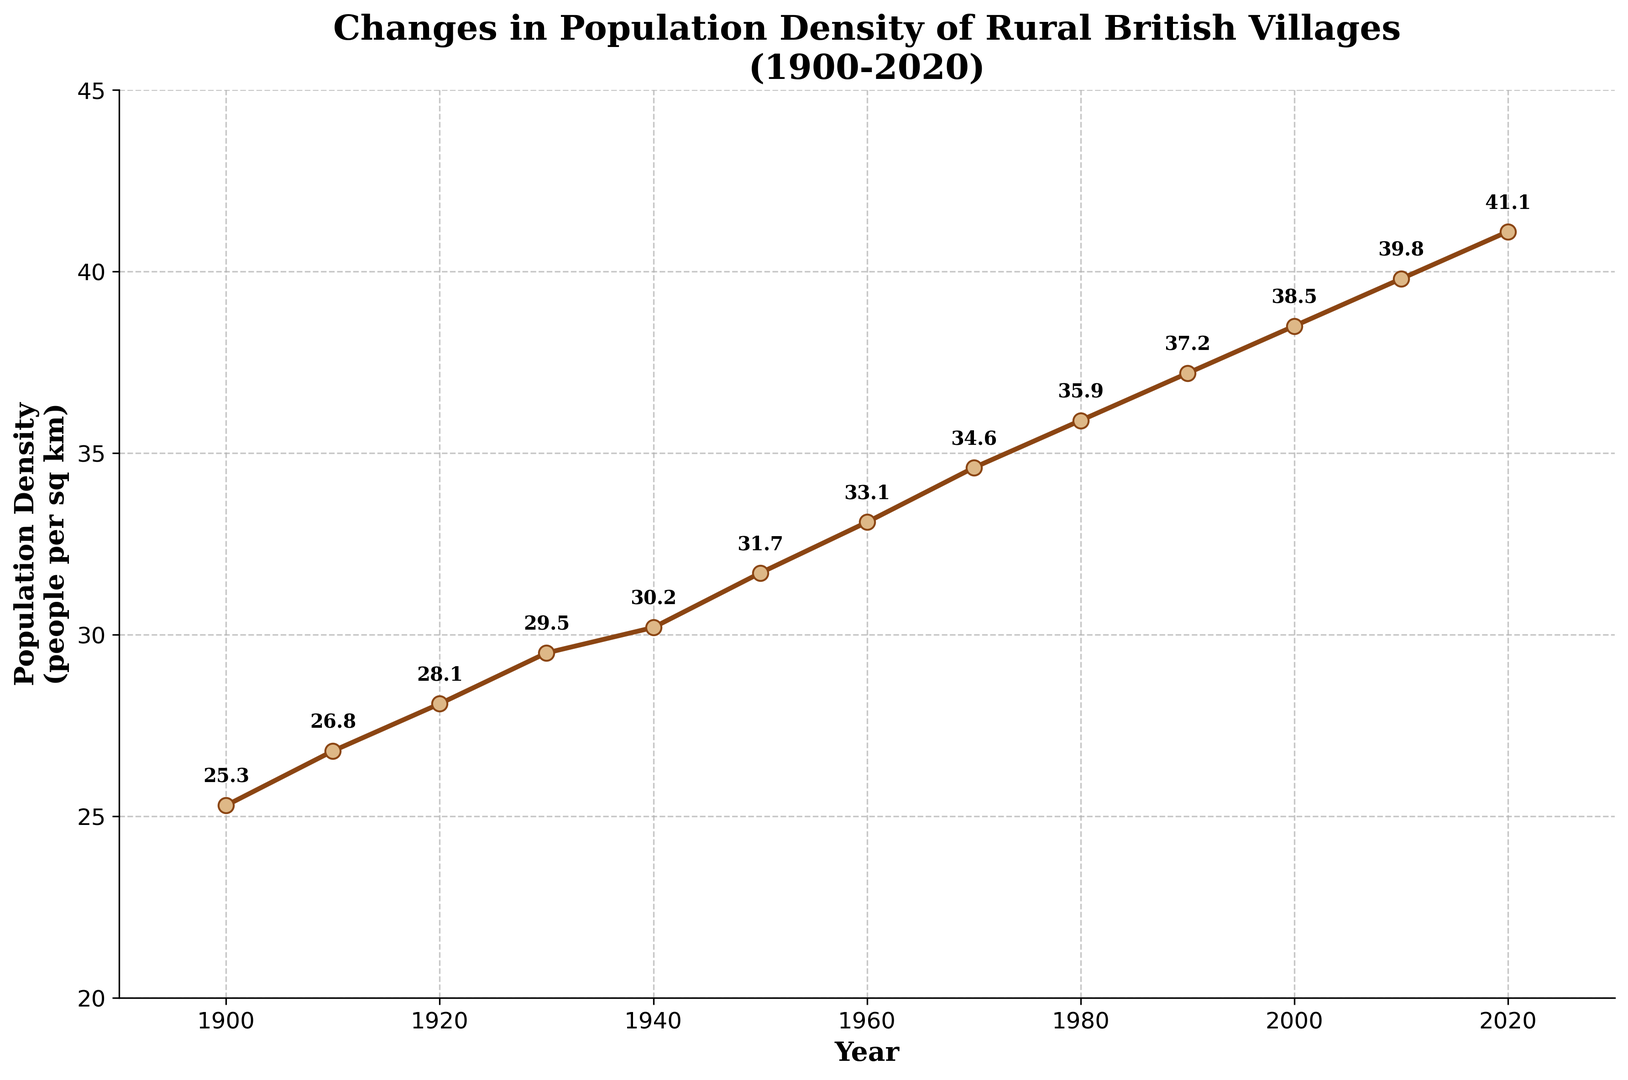How does the population density in 1920 compare to that in 2020? To find the population density difference between 1920 and 2020, look at the chart and identify the values for these years. In 1920, the population density is 28.1 people per sq km. In 2020, it is 41.1 people per sq km. The difference is calculated as 41.1 - 28.1 = 13.0.
Answer: 13.0 In which decade did the population density see the largest increase? To determine the decade with the largest increase, calculate the increase for each decade by subtracting the population density at the beginning of the decade from that at the end. Compare these increases to find the highest. The 2010s show the largest increase from 39.8 in 2010 to 41.1 in 2020, an increase of 1.3. All other decades have smaller increases.
Answer: 2010s What is the average population density from 1900 to 2020? The average population density is found by summing the population densities for all given years and dividing by the number of years. The sum of population densities is (25.3 + 26.8 + 28.1 + 29.5 + 30.2 + 31.7 + 33.1 + 34.6 + 35.9 + 37.2 + 38.5 + 39.8 + 41.1) = 431.8. There are 13 data points, so the average is 431.8 / 13 = 33.22.
Answer: 33.22 How does the population density in 1900 differ visually from that in 1950? Looking at the chart, the population density value for 1900 is one of the lowest values at the far left, marked by the point at 25.3. In 1950, density has increased to 31.7, indicated by the point higher on the vertical axis. The distance between these points on the vertical axis visually represents the increase.
Answer: 6.4 higher in 1950 What's the overall trend of the population density from 1900 to 2020? Observing the chart from left (1900) to right (2020), the population density shows a consistent upward trend. The line ascends steadily with values increasing from 25.3 in 1900 to 41.1 in 2020, indicating a continuous rise over the years.
Answer: Upward trend When did the population density cross the 30 people per sq km mark? Refer to the y-axis and find where the population density first reaches or exceeds 30 people per sq km. In the chart, this happens between 1930 and 1940, specifically in 1940 where density is 30.2.
Answer: 1940 What is the median population density value over these years? To find the median, the population densities must be listed in numerical order: 25.3, 26.8, 28.1, 29.5, 30.2, 31.7, 33.1, 34.6, 35.9, 37.2, 38.5, 39.8, 41.1. With 13 values, the median is the 7th value in this ordered list, which is 33.1.
Answer: 33.1 Which decade had the smallest relative increase in population density? Calculate the relative increase for each decade as (end value - start value) / start value. Compare these values for each decade. The smallest relative increase is in the 1900s: (26.8 - 25.3) / 25.3 = 0.059 (or 5.9%). All other relative increases are higher.
Answer: 1900s 